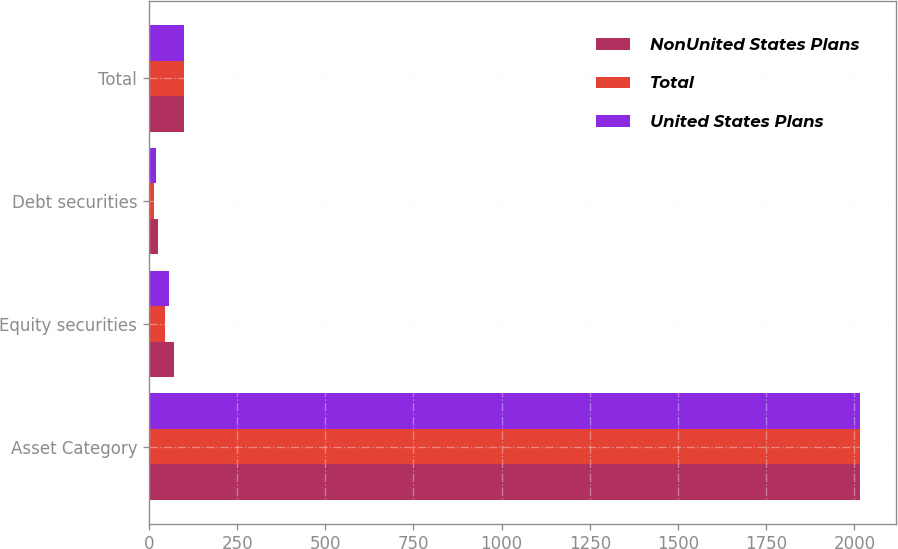Convert chart to OTSL. <chart><loc_0><loc_0><loc_500><loc_500><stacked_bar_chart><ecel><fcel>Asset Category<fcel>Equity securities<fcel>Debt securities<fcel>Total<nl><fcel>NonUnited States Plans<fcel>2016<fcel>70.09<fcel>24.94<fcel>100<nl><fcel>Total<fcel>2016<fcel>46.09<fcel>14.42<fcel>100<nl><fcel>United States Plans<fcel>2016<fcel>57.43<fcel>19.39<fcel>100<nl></chart> 